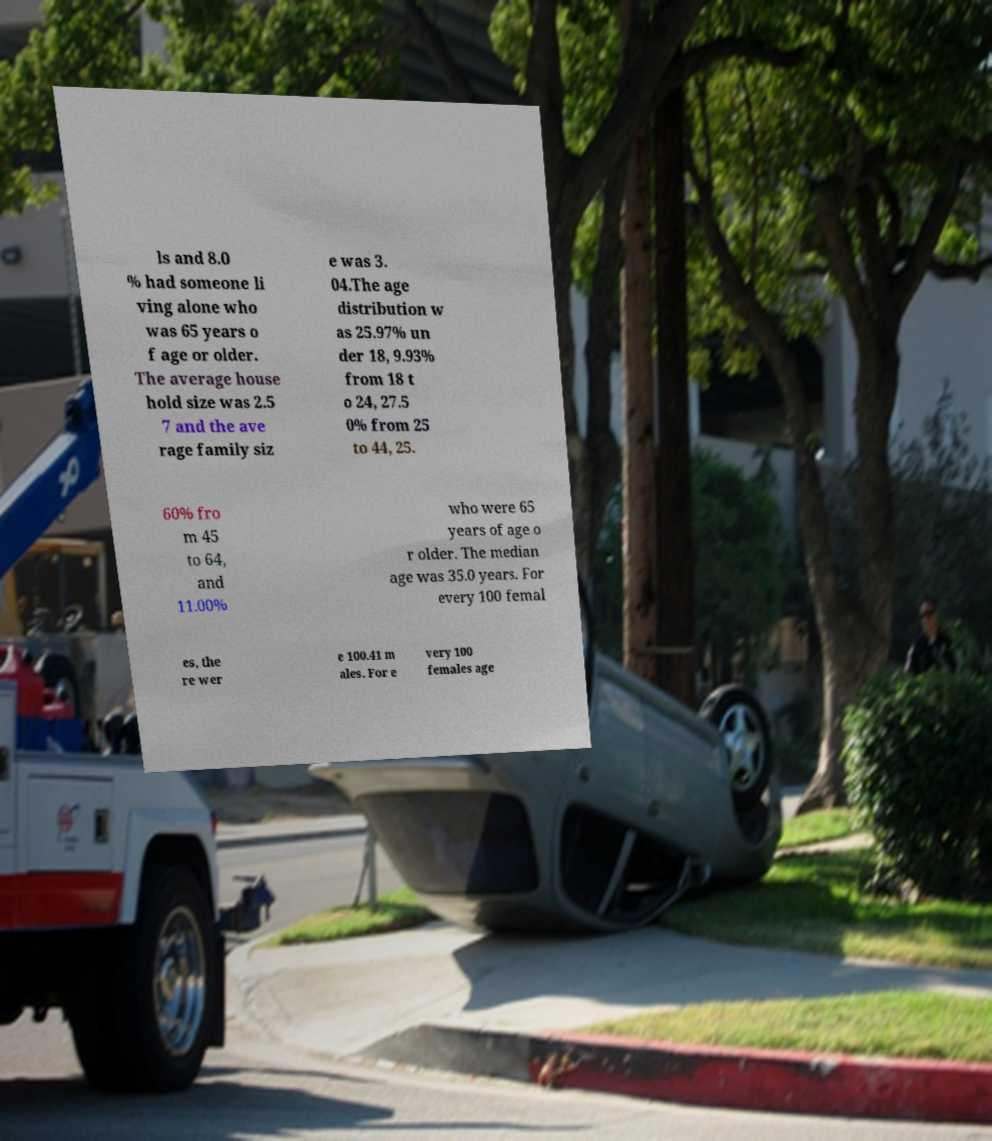Please read and relay the text visible in this image. What does it say? ls and 8.0 % had someone li ving alone who was 65 years o f age or older. The average house hold size was 2.5 7 and the ave rage family siz e was 3. 04.The age distribution w as 25.97% un der 18, 9.93% from 18 t o 24, 27.5 0% from 25 to 44, 25. 60% fro m 45 to 64, and 11.00% who were 65 years of age o r older. The median age was 35.0 years. For every 100 femal es, the re wer e 100.41 m ales. For e very 100 females age 